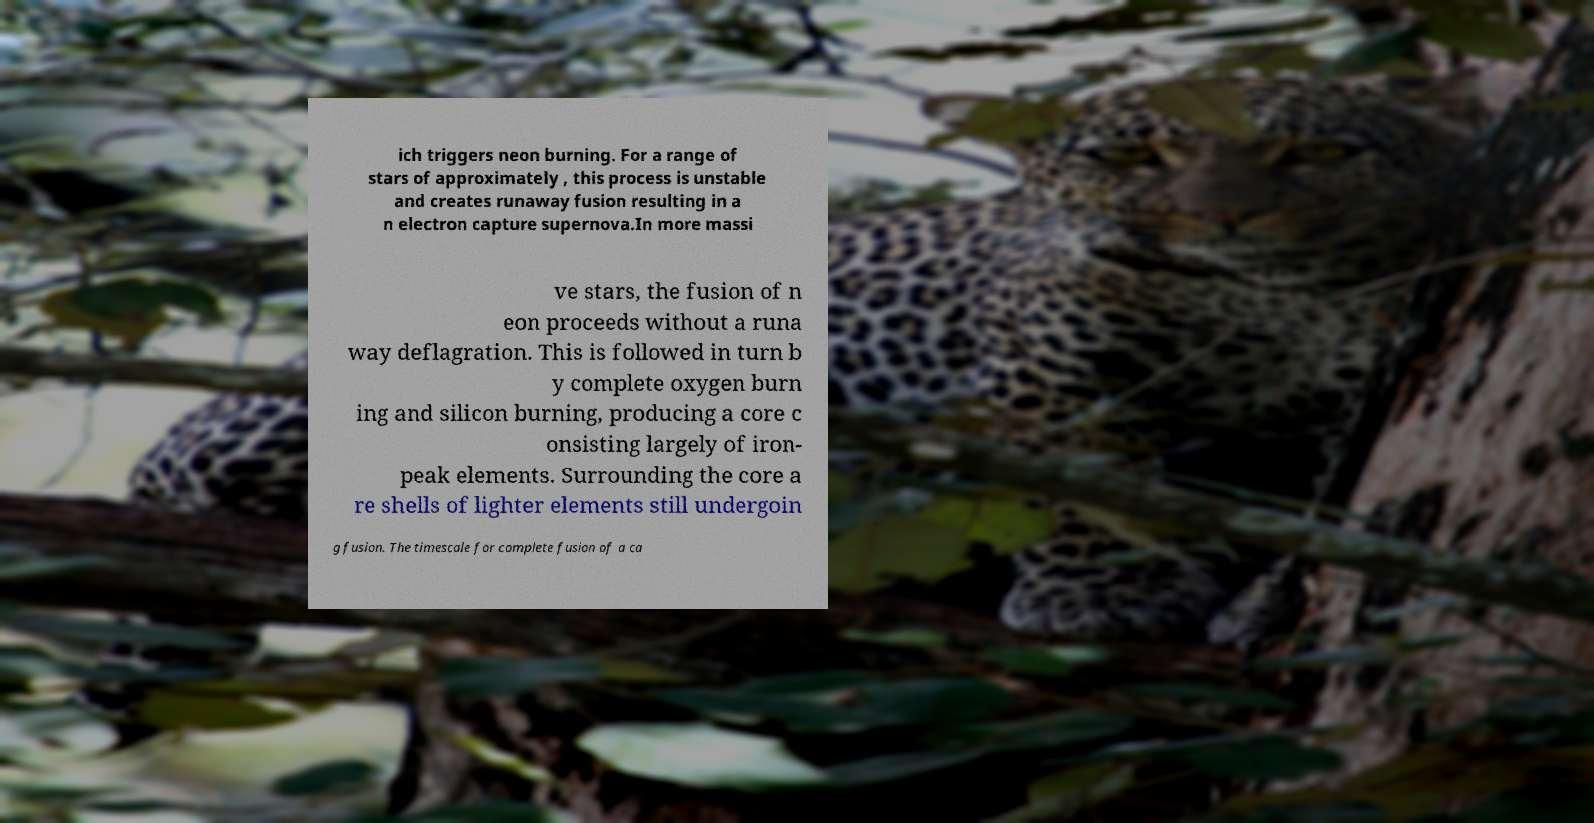Please read and relay the text visible in this image. What does it say? ich triggers neon burning. For a range of stars of approximately , this process is unstable and creates runaway fusion resulting in a n electron capture supernova.In more massi ve stars, the fusion of n eon proceeds without a runa way deflagration. This is followed in turn b y complete oxygen burn ing and silicon burning, producing a core c onsisting largely of iron- peak elements. Surrounding the core a re shells of lighter elements still undergoin g fusion. The timescale for complete fusion of a ca 